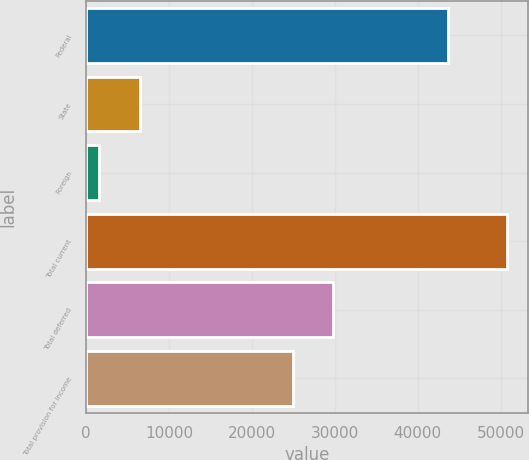<chart> <loc_0><loc_0><loc_500><loc_500><bar_chart><fcel>Federal<fcel>State<fcel>Foreign<fcel>Total current<fcel>Total deferred<fcel>Total provision for income<nl><fcel>43706<fcel>6508.6<fcel>1588<fcel>50794<fcel>29827.6<fcel>24907<nl></chart> 